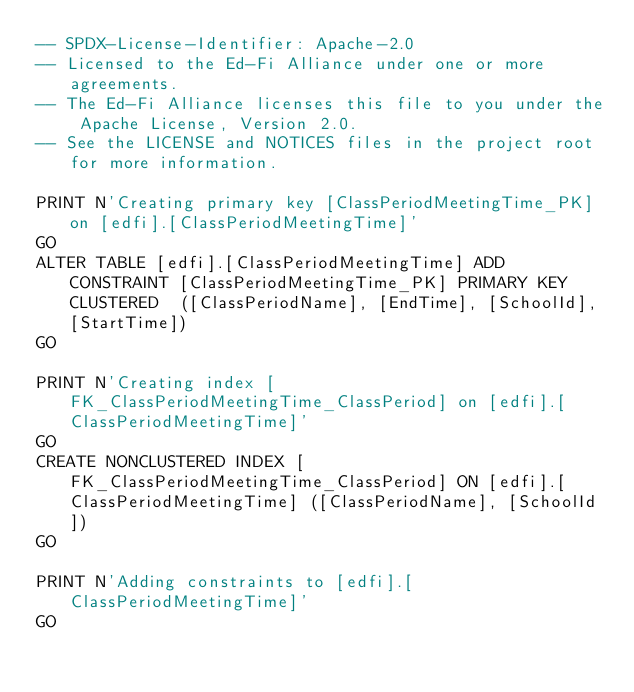<code> <loc_0><loc_0><loc_500><loc_500><_SQL_>-- SPDX-License-Identifier: Apache-2.0
-- Licensed to the Ed-Fi Alliance under one or more agreements.
-- The Ed-Fi Alliance licenses this file to you under the Apache License, Version 2.0.
-- See the LICENSE and NOTICES files in the project root for more information.

PRINT N'Creating primary key [ClassPeriodMeetingTime_PK] on [edfi].[ClassPeriodMeetingTime]'
GO
ALTER TABLE [edfi].[ClassPeriodMeetingTime] ADD CONSTRAINT [ClassPeriodMeetingTime_PK] PRIMARY KEY CLUSTERED  ([ClassPeriodName], [EndTime], [SchoolId], [StartTime])
GO

PRINT N'Creating index [FK_ClassPeriodMeetingTime_ClassPeriod] on [edfi].[ClassPeriodMeetingTime]'
GO
CREATE NONCLUSTERED INDEX [FK_ClassPeriodMeetingTime_ClassPeriod] ON [edfi].[ClassPeriodMeetingTime] ([ClassPeriodName], [SchoolId])
GO

PRINT N'Adding constraints to [edfi].[ClassPeriodMeetingTime]'
GO</code> 